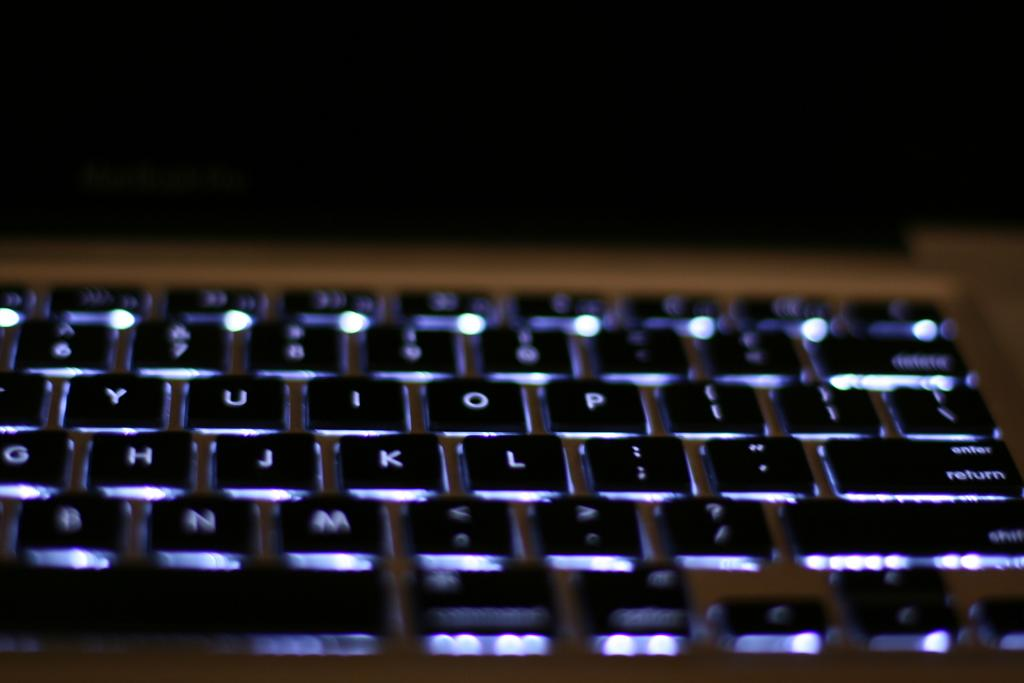Provide a one-sentence caption for the provided image. Keyboard with alphabet buttons, return button, and shift button. 